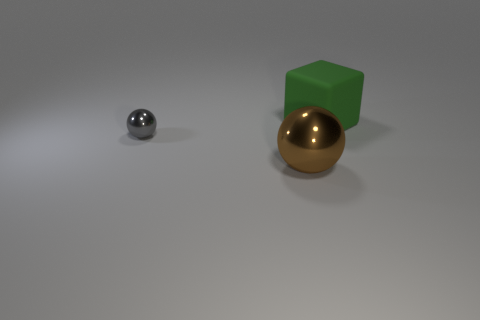Is there anything else that is made of the same material as the big block?
Offer a very short reply. No. Is the shape of the metal object that is to the right of the gray thing the same as  the tiny object?
Your response must be concise. Yes. Are there any other things that have the same shape as the tiny metallic object?
Provide a succinct answer. Yes. There is a metallic object left of the big thing left of the big green rubber block; what is its shape?
Your response must be concise. Sphere. How many gray things are made of the same material as the large brown ball?
Keep it short and to the point. 1. There is another object that is the same material as the small gray thing; what color is it?
Your response must be concise. Brown. There is a ball on the left side of the large thing left of the object that is behind the tiny object; how big is it?
Give a very brief answer. Small. Are there fewer large matte spheres than metal objects?
Your answer should be compact. Yes. What color is the big shiny thing that is the same shape as the small gray object?
Ensure brevity in your answer.  Brown. There is a shiny sphere that is in front of the object left of the big sphere; is there a metal ball that is behind it?
Give a very brief answer. Yes. 